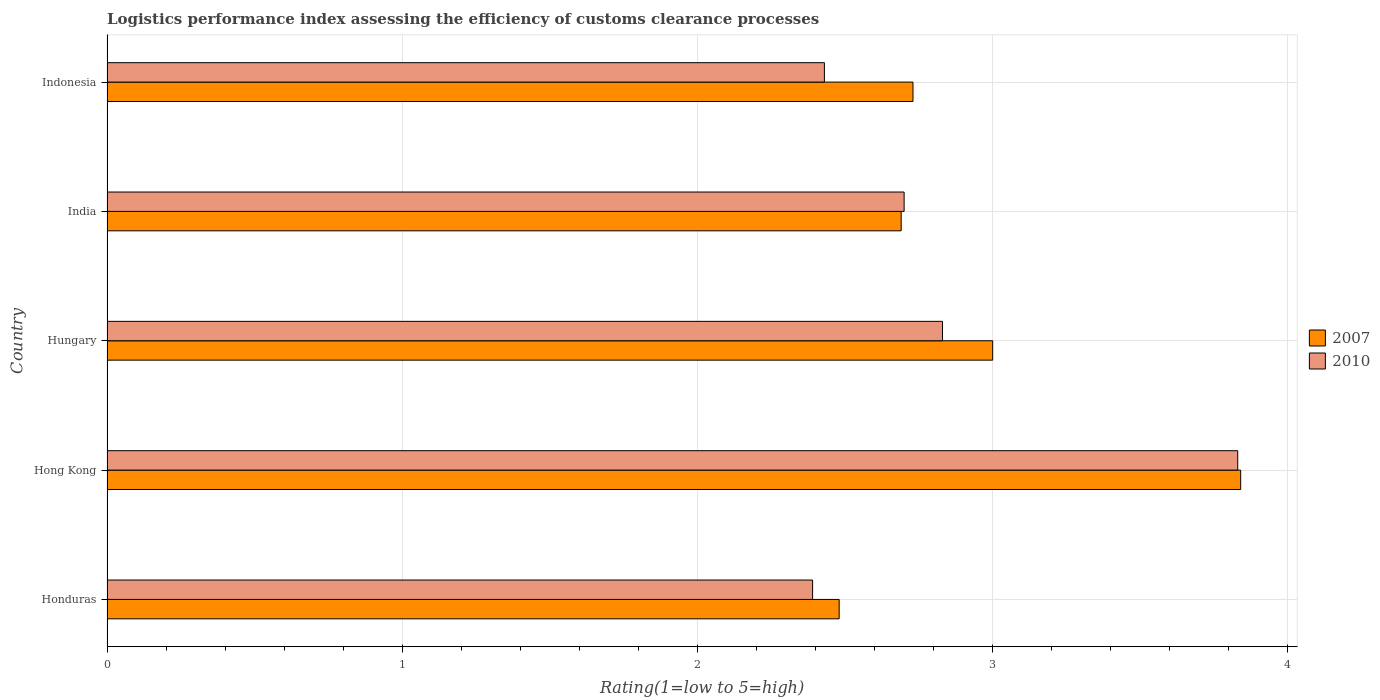Are the number of bars per tick equal to the number of legend labels?
Provide a short and direct response. Yes. Are the number of bars on each tick of the Y-axis equal?
Your response must be concise. Yes. How many bars are there on the 4th tick from the bottom?
Keep it short and to the point. 2. What is the label of the 1st group of bars from the top?
Offer a very short reply. Indonesia. In how many cases, is the number of bars for a given country not equal to the number of legend labels?
Your answer should be very brief. 0. What is the Logistic performance index in 2010 in Indonesia?
Offer a terse response. 2.43. Across all countries, what is the maximum Logistic performance index in 2010?
Provide a short and direct response. 3.83. Across all countries, what is the minimum Logistic performance index in 2007?
Give a very brief answer. 2.48. In which country was the Logistic performance index in 2007 maximum?
Your answer should be compact. Hong Kong. In which country was the Logistic performance index in 2007 minimum?
Make the answer very short. Honduras. What is the total Logistic performance index in 2010 in the graph?
Your response must be concise. 14.18. What is the difference between the Logistic performance index in 2010 in Hungary and that in Indonesia?
Make the answer very short. 0.4. What is the difference between the Logistic performance index in 2010 in India and the Logistic performance index in 2007 in Hungary?
Offer a terse response. -0.3. What is the average Logistic performance index in 2007 per country?
Offer a terse response. 2.95. What is the difference between the Logistic performance index in 2010 and Logistic performance index in 2007 in India?
Ensure brevity in your answer.  0.01. What is the ratio of the Logistic performance index in 2007 in Honduras to that in Hungary?
Ensure brevity in your answer.  0.83. What is the difference between the highest and the second highest Logistic performance index in 2007?
Your answer should be very brief. 0.84. What is the difference between the highest and the lowest Logistic performance index in 2010?
Your answer should be very brief. 1.44. In how many countries, is the Logistic performance index in 2007 greater than the average Logistic performance index in 2007 taken over all countries?
Provide a short and direct response. 2. Are all the bars in the graph horizontal?
Make the answer very short. Yes. How many countries are there in the graph?
Offer a terse response. 5. What is the difference between two consecutive major ticks on the X-axis?
Provide a succinct answer. 1. Does the graph contain any zero values?
Make the answer very short. No. Does the graph contain grids?
Make the answer very short. Yes. Where does the legend appear in the graph?
Give a very brief answer. Center right. How many legend labels are there?
Your answer should be very brief. 2. What is the title of the graph?
Make the answer very short. Logistics performance index assessing the efficiency of customs clearance processes. Does "2000" appear as one of the legend labels in the graph?
Provide a succinct answer. No. What is the label or title of the X-axis?
Ensure brevity in your answer.  Rating(1=low to 5=high). What is the label or title of the Y-axis?
Keep it short and to the point. Country. What is the Rating(1=low to 5=high) in 2007 in Honduras?
Make the answer very short. 2.48. What is the Rating(1=low to 5=high) of 2010 in Honduras?
Your answer should be compact. 2.39. What is the Rating(1=low to 5=high) of 2007 in Hong Kong?
Ensure brevity in your answer.  3.84. What is the Rating(1=low to 5=high) in 2010 in Hong Kong?
Offer a very short reply. 3.83. What is the Rating(1=low to 5=high) in 2010 in Hungary?
Offer a terse response. 2.83. What is the Rating(1=low to 5=high) of 2007 in India?
Ensure brevity in your answer.  2.69. What is the Rating(1=low to 5=high) of 2007 in Indonesia?
Make the answer very short. 2.73. What is the Rating(1=low to 5=high) of 2010 in Indonesia?
Offer a terse response. 2.43. Across all countries, what is the maximum Rating(1=low to 5=high) of 2007?
Offer a very short reply. 3.84. Across all countries, what is the maximum Rating(1=low to 5=high) of 2010?
Offer a terse response. 3.83. Across all countries, what is the minimum Rating(1=low to 5=high) of 2007?
Give a very brief answer. 2.48. Across all countries, what is the minimum Rating(1=low to 5=high) in 2010?
Your answer should be very brief. 2.39. What is the total Rating(1=low to 5=high) in 2007 in the graph?
Make the answer very short. 14.74. What is the total Rating(1=low to 5=high) of 2010 in the graph?
Give a very brief answer. 14.18. What is the difference between the Rating(1=low to 5=high) in 2007 in Honduras and that in Hong Kong?
Provide a succinct answer. -1.36. What is the difference between the Rating(1=low to 5=high) of 2010 in Honduras and that in Hong Kong?
Your answer should be very brief. -1.44. What is the difference between the Rating(1=low to 5=high) in 2007 in Honduras and that in Hungary?
Give a very brief answer. -0.52. What is the difference between the Rating(1=low to 5=high) in 2010 in Honduras and that in Hungary?
Your answer should be compact. -0.44. What is the difference between the Rating(1=low to 5=high) of 2007 in Honduras and that in India?
Offer a very short reply. -0.21. What is the difference between the Rating(1=low to 5=high) in 2010 in Honduras and that in India?
Give a very brief answer. -0.31. What is the difference between the Rating(1=low to 5=high) in 2010 in Honduras and that in Indonesia?
Offer a terse response. -0.04. What is the difference between the Rating(1=low to 5=high) in 2007 in Hong Kong and that in Hungary?
Provide a succinct answer. 0.84. What is the difference between the Rating(1=low to 5=high) in 2007 in Hong Kong and that in India?
Your answer should be compact. 1.15. What is the difference between the Rating(1=low to 5=high) in 2010 in Hong Kong and that in India?
Offer a terse response. 1.13. What is the difference between the Rating(1=low to 5=high) in 2007 in Hong Kong and that in Indonesia?
Give a very brief answer. 1.11. What is the difference between the Rating(1=low to 5=high) of 2007 in Hungary and that in India?
Offer a very short reply. 0.31. What is the difference between the Rating(1=low to 5=high) of 2010 in Hungary and that in India?
Provide a succinct answer. 0.13. What is the difference between the Rating(1=low to 5=high) in 2007 in Hungary and that in Indonesia?
Offer a terse response. 0.27. What is the difference between the Rating(1=low to 5=high) in 2010 in Hungary and that in Indonesia?
Your answer should be very brief. 0.4. What is the difference between the Rating(1=low to 5=high) in 2007 in India and that in Indonesia?
Provide a succinct answer. -0.04. What is the difference between the Rating(1=low to 5=high) in 2010 in India and that in Indonesia?
Offer a very short reply. 0.27. What is the difference between the Rating(1=low to 5=high) in 2007 in Honduras and the Rating(1=low to 5=high) in 2010 in Hong Kong?
Keep it short and to the point. -1.35. What is the difference between the Rating(1=low to 5=high) in 2007 in Honduras and the Rating(1=low to 5=high) in 2010 in Hungary?
Offer a very short reply. -0.35. What is the difference between the Rating(1=low to 5=high) in 2007 in Honduras and the Rating(1=low to 5=high) in 2010 in India?
Offer a terse response. -0.22. What is the difference between the Rating(1=low to 5=high) in 2007 in Hong Kong and the Rating(1=low to 5=high) in 2010 in Hungary?
Give a very brief answer. 1.01. What is the difference between the Rating(1=low to 5=high) in 2007 in Hong Kong and the Rating(1=low to 5=high) in 2010 in India?
Provide a short and direct response. 1.14. What is the difference between the Rating(1=low to 5=high) of 2007 in Hong Kong and the Rating(1=low to 5=high) of 2010 in Indonesia?
Give a very brief answer. 1.41. What is the difference between the Rating(1=low to 5=high) of 2007 in Hungary and the Rating(1=low to 5=high) of 2010 in Indonesia?
Give a very brief answer. 0.57. What is the difference between the Rating(1=low to 5=high) in 2007 in India and the Rating(1=low to 5=high) in 2010 in Indonesia?
Offer a terse response. 0.26. What is the average Rating(1=low to 5=high) of 2007 per country?
Provide a short and direct response. 2.95. What is the average Rating(1=low to 5=high) in 2010 per country?
Offer a terse response. 2.84. What is the difference between the Rating(1=low to 5=high) of 2007 and Rating(1=low to 5=high) of 2010 in Honduras?
Provide a succinct answer. 0.09. What is the difference between the Rating(1=low to 5=high) in 2007 and Rating(1=low to 5=high) in 2010 in Hong Kong?
Give a very brief answer. 0.01. What is the difference between the Rating(1=low to 5=high) of 2007 and Rating(1=low to 5=high) of 2010 in Hungary?
Offer a terse response. 0.17. What is the difference between the Rating(1=low to 5=high) in 2007 and Rating(1=low to 5=high) in 2010 in India?
Provide a short and direct response. -0.01. What is the difference between the Rating(1=low to 5=high) of 2007 and Rating(1=low to 5=high) of 2010 in Indonesia?
Ensure brevity in your answer.  0.3. What is the ratio of the Rating(1=low to 5=high) of 2007 in Honduras to that in Hong Kong?
Offer a terse response. 0.65. What is the ratio of the Rating(1=low to 5=high) in 2010 in Honduras to that in Hong Kong?
Ensure brevity in your answer.  0.62. What is the ratio of the Rating(1=low to 5=high) of 2007 in Honduras to that in Hungary?
Provide a short and direct response. 0.83. What is the ratio of the Rating(1=low to 5=high) of 2010 in Honduras to that in Hungary?
Provide a succinct answer. 0.84. What is the ratio of the Rating(1=low to 5=high) in 2007 in Honduras to that in India?
Provide a succinct answer. 0.92. What is the ratio of the Rating(1=low to 5=high) of 2010 in Honduras to that in India?
Keep it short and to the point. 0.89. What is the ratio of the Rating(1=low to 5=high) in 2007 in Honduras to that in Indonesia?
Make the answer very short. 0.91. What is the ratio of the Rating(1=low to 5=high) of 2010 in Honduras to that in Indonesia?
Your answer should be very brief. 0.98. What is the ratio of the Rating(1=low to 5=high) in 2007 in Hong Kong to that in Hungary?
Your response must be concise. 1.28. What is the ratio of the Rating(1=low to 5=high) in 2010 in Hong Kong to that in Hungary?
Offer a terse response. 1.35. What is the ratio of the Rating(1=low to 5=high) of 2007 in Hong Kong to that in India?
Keep it short and to the point. 1.43. What is the ratio of the Rating(1=low to 5=high) in 2010 in Hong Kong to that in India?
Provide a short and direct response. 1.42. What is the ratio of the Rating(1=low to 5=high) of 2007 in Hong Kong to that in Indonesia?
Ensure brevity in your answer.  1.41. What is the ratio of the Rating(1=low to 5=high) of 2010 in Hong Kong to that in Indonesia?
Your response must be concise. 1.58. What is the ratio of the Rating(1=low to 5=high) in 2007 in Hungary to that in India?
Your answer should be compact. 1.12. What is the ratio of the Rating(1=low to 5=high) in 2010 in Hungary to that in India?
Offer a terse response. 1.05. What is the ratio of the Rating(1=low to 5=high) in 2007 in Hungary to that in Indonesia?
Make the answer very short. 1.1. What is the ratio of the Rating(1=low to 5=high) of 2010 in Hungary to that in Indonesia?
Ensure brevity in your answer.  1.16. What is the ratio of the Rating(1=low to 5=high) of 2007 in India to that in Indonesia?
Your answer should be compact. 0.99. What is the ratio of the Rating(1=low to 5=high) in 2010 in India to that in Indonesia?
Provide a succinct answer. 1.11. What is the difference between the highest and the second highest Rating(1=low to 5=high) of 2007?
Your response must be concise. 0.84. What is the difference between the highest and the lowest Rating(1=low to 5=high) in 2007?
Provide a succinct answer. 1.36. What is the difference between the highest and the lowest Rating(1=low to 5=high) in 2010?
Your answer should be compact. 1.44. 